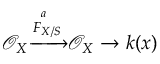Convert formula to latex. <formula><loc_0><loc_0><loc_500><loc_500>{ \mathcal { O } } _ { X } { \xrightarrow { { { F } } _ { X / S } ^ { a } } } { \mathcal { O } } _ { X } \to k ( x )</formula> 